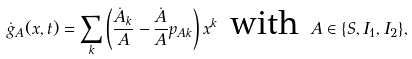<formula> <loc_0><loc_0><loc_500><loc_500>\dot { g } _ { A } ( x , t ) = \sum _ { k } \left ( \frac { \dot { A } _ { k } } { A } - \frac { \dot { A } } { A } p _ { A k } \right ) x ^ { k } \text { with } A \in \{ S , I _ { 1 } , I _ { 2 } \} ,</formula> 